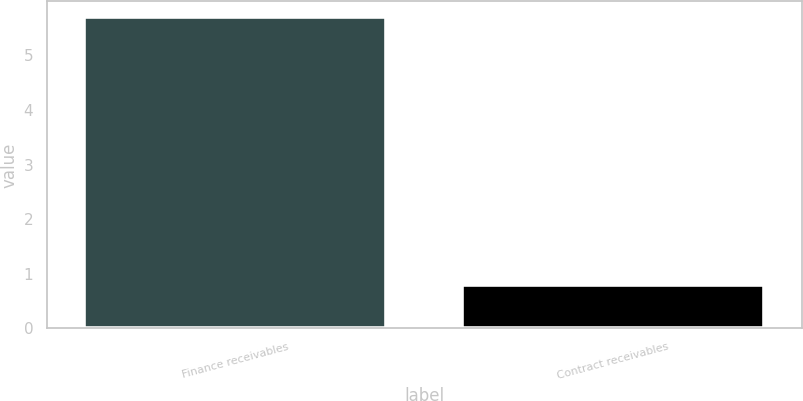Convert chart. <chart><loc_0><loc_0><loc_500><loc_500><bar_chart><fcel>Finance receivables<fcel>Contract receivables<nl><fcel>5.7<fcel>0.8<nl></chart> 